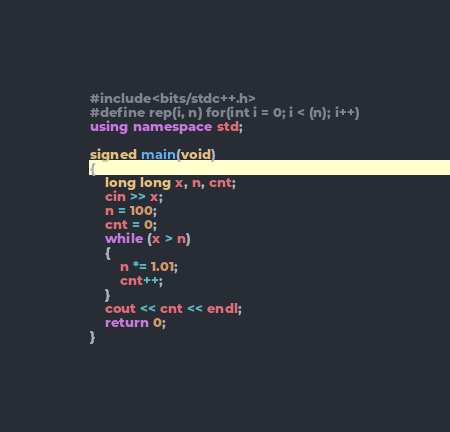<code> <loc_0><loc_0><loc_500><loc_500><_C++_>#include<bits/stdc++.h>
#define rep(i, n) for(int i = 0; i < (n); i++)
using namespace std;

signed main(void)
{
	long long x, n, cnt;
	cin >> x;
	n = 100;
	cnt = 0;
	while (x > n)
	{
		n *= 1.01;
		cnt++;
	}
	cout << cnt << endl;
	return 0;
}
</code> 